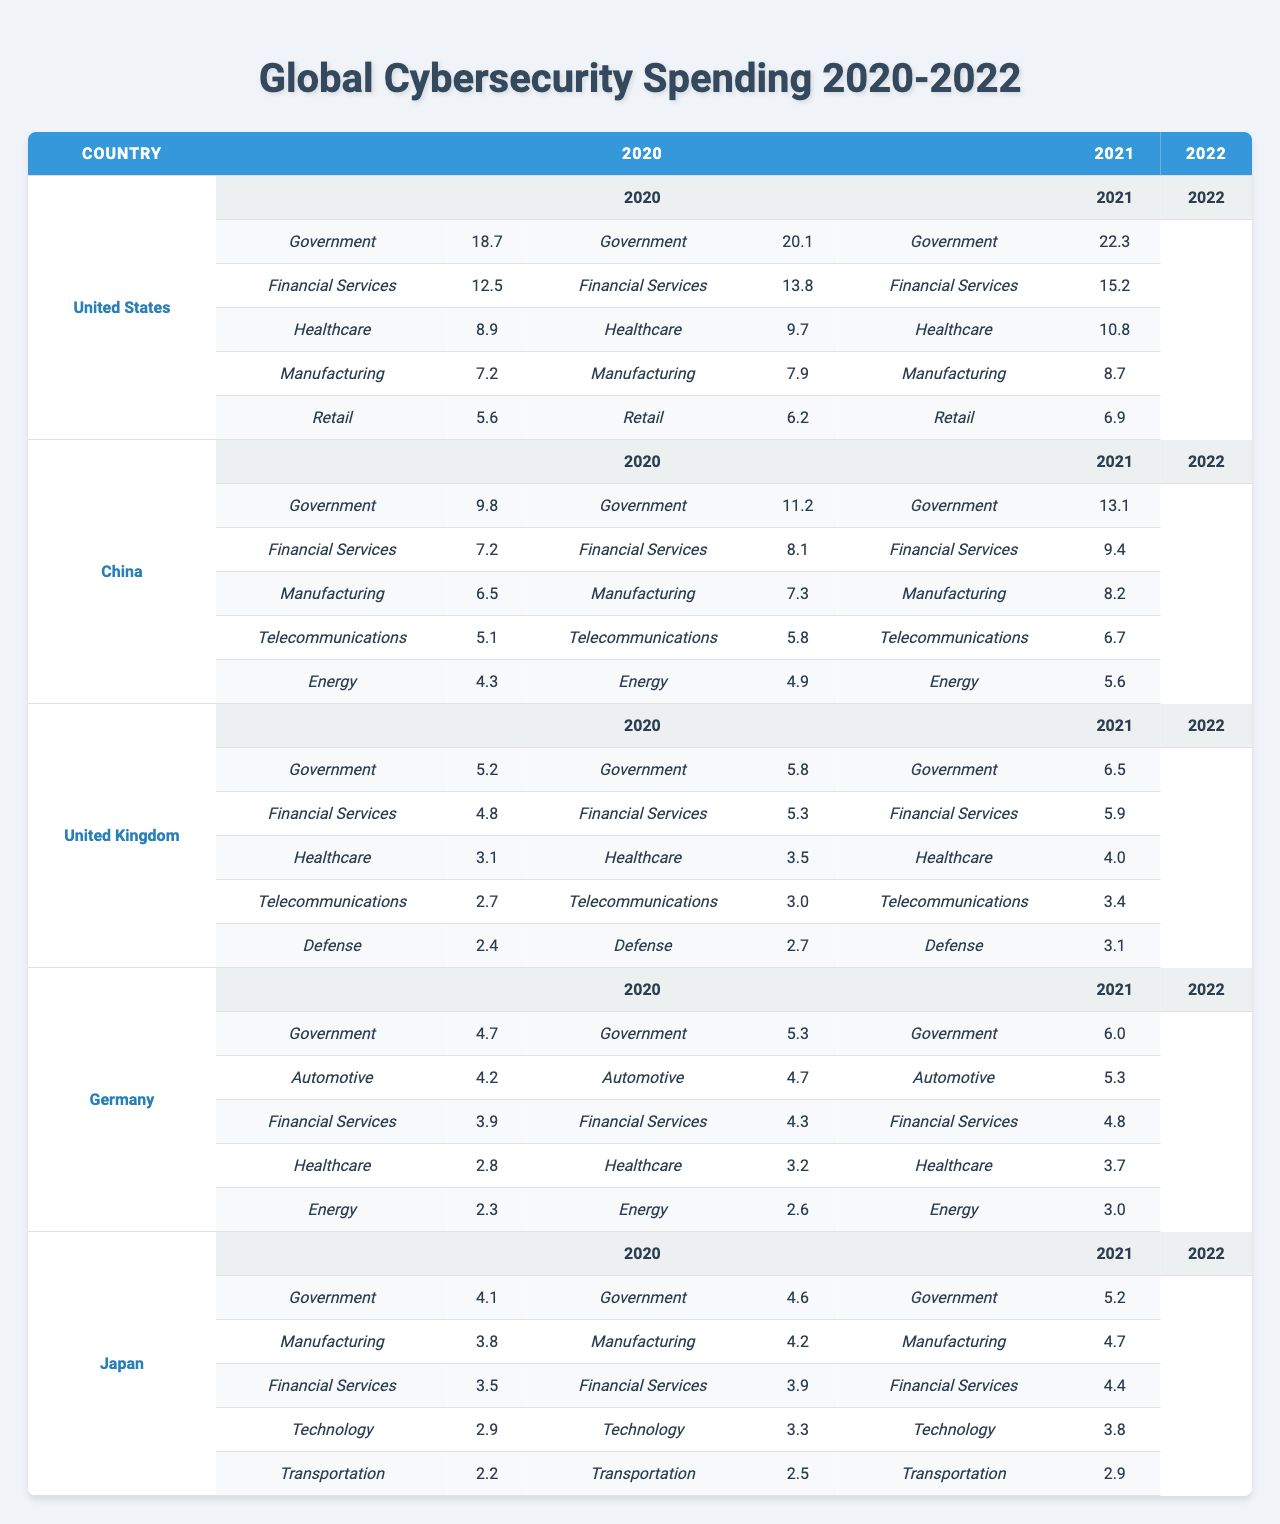What was the highest amount spent on cybersecurity by the United States in 2022? In 2022, the United States spent the most on cybersecurity in the Government sector, which amounted to 22.3 billion dollars.
Answer: 22.3 billion dollars Which sector saw the most significant increase in spending in China from 2020 to 2022? Comparing the years 2020 and 2022 in China, the Government sector saw the highest increase from 9.8 billion dollars to 13.1 billion dollars, an increase of 3.3 billion dollars.
Answer: Government sector What was the average cybersecurity spending for Japan across all sectors in 2021? To calculate the average for Japan in 2021, we sum the spending across all sectors: (4.6 + 4.2 + 3.9 + 3.3 + 2.5) = 18.5 billion dollars. There are 5 sectors, so the average is 18.5 / 5 = 3.7 billion dollars.
Answer: 3.7 billion dollars Did Germany spend more on its Automotive sector than on its Healthcare sector in 2022? In 2022, Germany spent 5.3 billion dollars on the Automotive sector and 3.7 billion dollars on the Healthcare sector. Since 5.3 is greater than 3.7, Germany did spend more on Automotive.
Answer: Yes What was the difference in cybersecurity spending for the Financial Services sector between the United Kingdom in 2020 and 2022? The spending on Financial Services in the United Kingdom was 4.8 billion dollars in 2020 and 5.9 billion dollars in 2022. The difference is 5.9 - 4.8 = 1.1 billion dollars.
Answer: 1.1 billion dollars Which country had the second-highest cybersecurity spending in the Government sector in 2021? In 2021, the United States had the highest spending in the Government sector with 20.1 billion dollars, while China was second with 11.2 billion dollars.
Answer: China What was the total cybersecurity spending for the Healthcare sector in the United States over the three years? The total spending for the Healthcare sector by the United States over the three years is calculated as follows: 8.9 (2020) + 9.7 (2021) + 10.8 (2022) = 29.4 billion dollars.
Answer: 29.4 billion dollars Which sector in the UK showed the least growth from 2020 to 2022? The sector with the least growth for the UK from 2020 to 2022 is the Defense sector, with an increase from 2.4 to 3.1 billion dollars, a growth of only 0.7 billion dollars.
Answer: Defense sector 